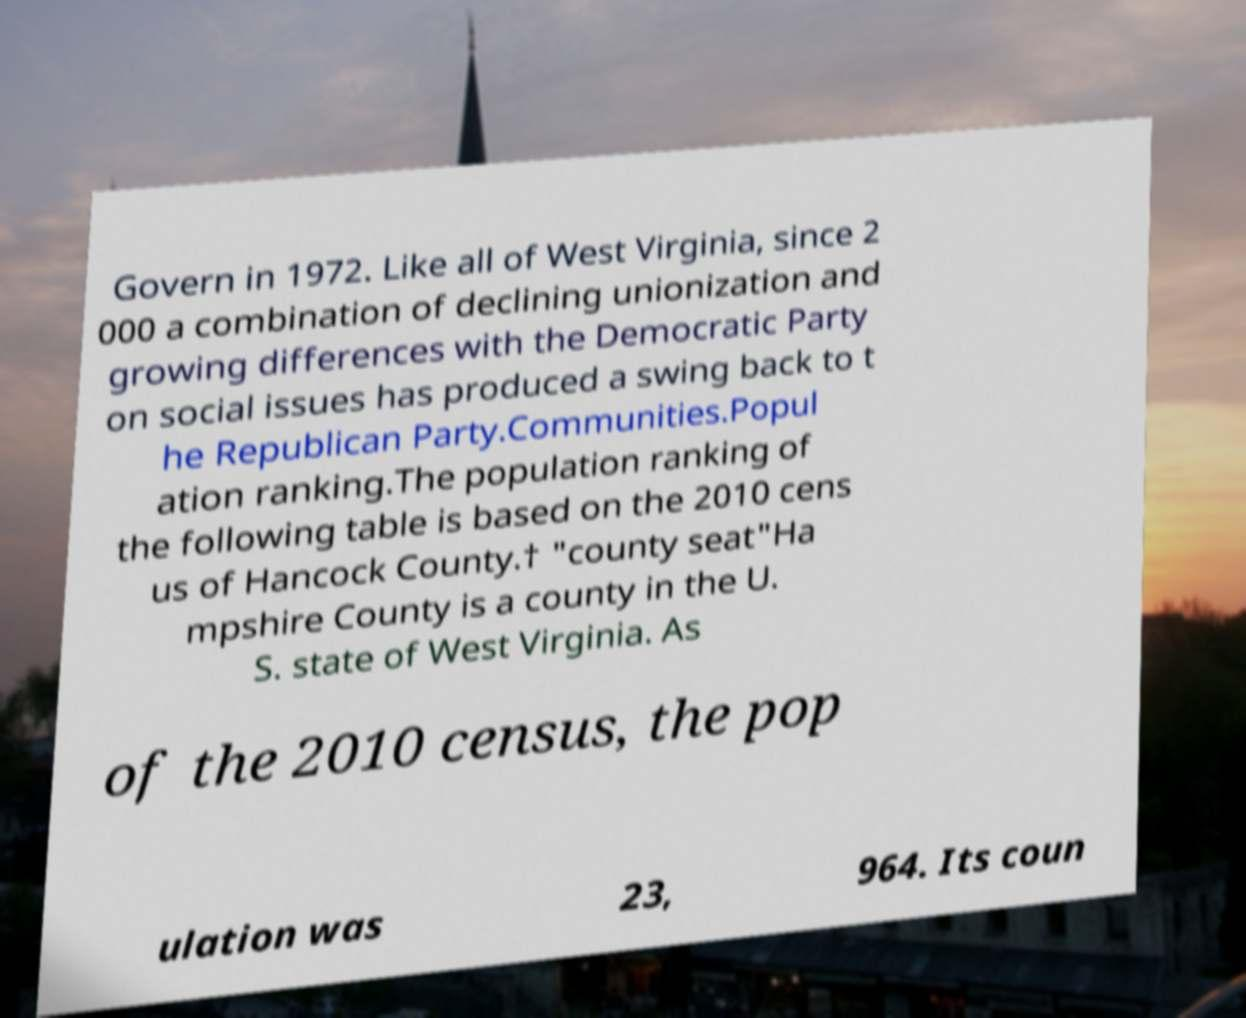What messages or text are displayed in this image? I need them in a readable, typed format. Govern in 1972. Like all of West Virginia, since 2 000 a combination of declining unionization and growing differences with the Democratic Party on social issues has produced a swing back to t he Republican Party.Communities.Popul ation ranking.The population ranking of the following table is based on the 2010 cens us of Hancock County.† "county seat"Ha mpshire County is a county in the U. S. state of West Virginia. As of the 2010 census, the pop ulation was 23, 964. Its coun 